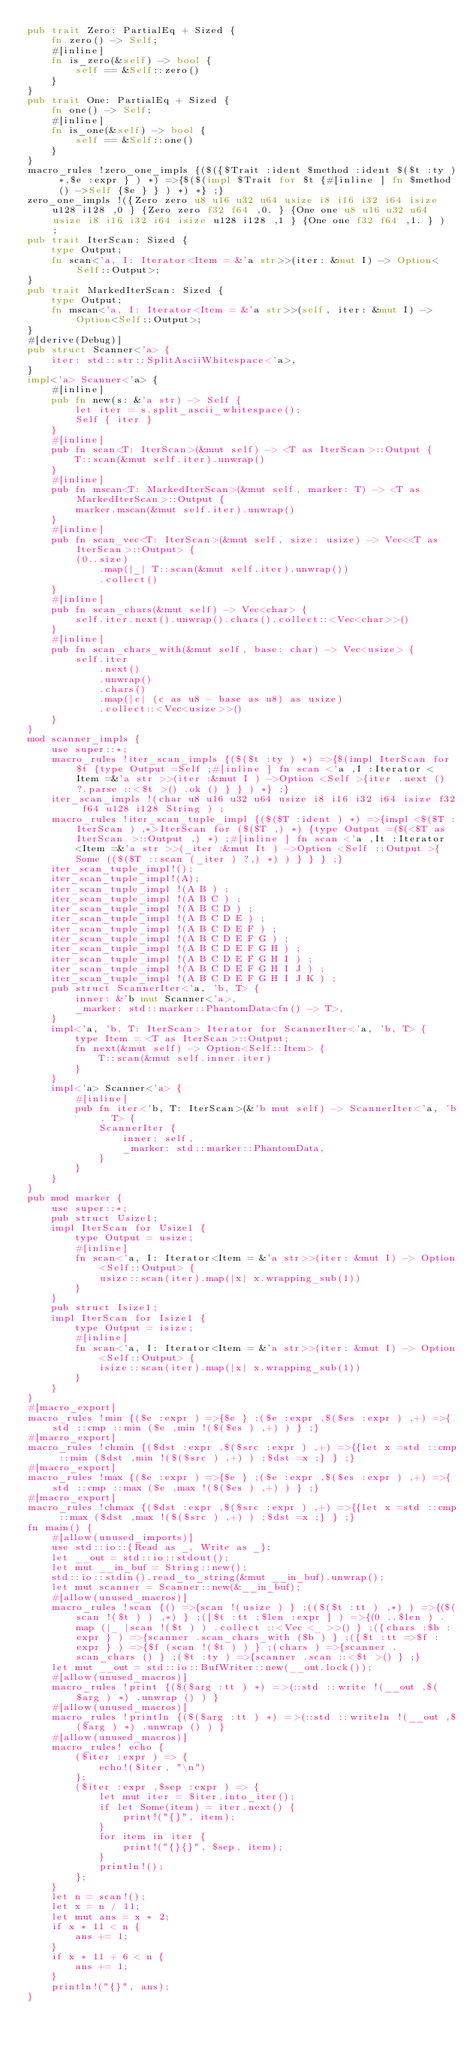Convert code to text. <code><loc_0><loc_0><loc_500><loc_500><_Rust_>pub trait Zero: PartialEq + Sized {
    fn zero() -> Self;
    #[inline]
    fn is_zero(&self) -> bool {
        self == &Self::zero()
    }
}
pub trait One: PartialEq + Sized {
    fn one() -> Self;
    #[inline]
    fn is_one(&self) -> bool {
        self == &Self::one()
    }
}
macro_rules !zero_one_impls {($({$Trait :ident $method :ident $($t :ty ) *,$e :expr } ) *) =>{$($(impl $Trait for $t {#[inline ] fn $method () ->Self {$e } } ) *) *} ;}
zero_one_impls !({Zero zero u8 u16 u32 u64 usize i8 i16 i32 i64 isize u128 i128 ,0 } {Zero zero f32 f64 ,0. } {One one u8 u16 u32 u64 usize i8 i16 i32 i64 isize u128 i128 ,1 } {One one f32 f64 ,1. } ) ;
pub trait IterScan: Sized {
    type Output;
    fn scan<'a, I: Iterator<Item = &'a str>>(iter: &mut I) -> Option<Self::Output>;
}
pub trait MarkedIterScan: Sized {
    type Output;
    fn mscan<'a, I: Iterator<Item = &'a str>>(self, iter: &mut I) -> Option<Self::Output>;
}
#[derive(Debug)]
pub struct Scanner<'a> {
    iter: std::str::SplitAsciiWhitespace<'a>,
}
impl<'a> Scanner<'a> {
    #[inline]
    pub fn new(s: &'a str) -> Self {
        let iter = s.split_ascii_whitespace();
        Self { iter }
    }
    #[inline]
    pub fn scan<T: IterScan>(&mut self) -> <T as IterScan>::Output {
        T::scan(&mut self.iter).unwrap()
    }
    #[inline]
    pub fn mscan<T: MarkedIterScan>(&mut self, marker: T) -> <T as MarkedIterScan>::Output {
        marker.mscan(&mut self.iter).unwrap()
    }
    #[inline]
    pub fn scan_vec<T: IterScan>(&mut self, size: usize) -> Vec<<T as IterScan>::Output> {
        (0..size)
            .map(|_| T::scan(&mut self.iter).unwrap())
            .collect()
    }
    #[inline]
    pub fn scan_chars(&mut self) -> Vec<char> {
        self.iter.next().unwrap().chars().collect::<Vec<char>>()
    }
    #[inline]
    pub fn scan_chars_with(&mut self, base: char) -> Vec<usize> {
        self.iter
            .next()
            .unwrap()
            .chars()
            .map(|c| (c as u8 - base as u8) as usize)
            .collect::<Vec<usize>>()
    }
}
mod scanner_impls {
    use super::*;
    macro_rules !iter_scan_impls {($($t :ty ) *) =>{$(impl IterScan for $t {type Output =Self ;#[inline ] fn scan <'a ,I :Iterator <Item =&'a str >>(iter :&mut I ) ->Option <Self >{iter .next () ?.parse ::<$t >() .ok () } } ) *} ;}
    iter_scan_impls !(char u8 u16 u32 u64 usize i8 i16 i32 i64 isize f32 f64 u128 i128 String ) ;
    macro_rules !iter_scan_tuple_impl {($($T :ident ) *) =>{impl <$($T :IterScan ) ,*>IterScan for ($($T ,) *) {type Output =($(<$T as IterScan >::Output ,) *) ;#[inline ] fn scan <'a ,It :Iterator <Item =&'a str >>(_iter :&mut It ) ->Option <Self ::Output >{Some (($($T ::scan (_iter ) ?,) *) ) } } } ;}
    iter_scan_tuple_impl!();
    iter_scan_tuple_impl!(A);
    iter_scan_tuple_impl !(A B ) ;
    iter_scan_tuple_impl !(A B C ) ;
    iter_scan_tuple_impl !(A B C D ) ;
    iter_scan_tuple_impl !(A B C D E ) ;
    iter_scan_tuple_impl !(A B C D E F ) ;
    iter_scan_tuple_impl !(A B C D E F G ) ;
    iter_scan_tuple_impl !(A B C D E F G H ) ;
    iter_scan_tuple_impl !(A B C D E F G H I ) ;
    iter_scan_tuple_impl !(A B C D E F G H I J ) ;
    iter_scan_tuple_impl !(A B C D E F G H I J K ) ;
    pub struct ScannerIter<'a, 'b, T> {
        inner: &'b mut Scanner<'a>,
        _marker: std::marker::PhantomData<fn() -> T>,
    }
    impl<'a, 'b, T: IterScan> Iterator for ScannerIter<'a, 'b, T> {
        type Item = <T as IterScan>::Output;
        fn next(&mut self) -> Option<Self::Item> {
            T::scan(&mut self.inner.iter)
        }
    }
    impl<'a> Scanner<'a> {
        #[inline]
        pub fn iter<'b, T: IterScan>(&'b mut self) -> ScannerIter<'a, 'b, T> {
            ScannerIter {
                inner: self,
                _marker: std::marker::PhantomData,
            }
        }
    }
}
pub mod marker {
    use super::*;
    pub struct Usize1;
    impl IterScan for Usize1 {
        type Output = usize;
        #[inline]
        fn scan<'a, I: Iterator<Item = &'a str>>(iter: &mut I) -> Option<Self::Output> {
            usize::scan(iter).map(|x| x.wrapping_sub(1))
        }
    }
    pub struct Isize1;
    impl IterScan for Isize1 {
        type Output = isize;
        #[inline]
        fn scan<'a, I: Iterator<Item = &'a str>>(iter: &mut I) -> Option<Self::Output> {
            isize::scan(iter).map(|x| x.wrapping_sub(1))
        }
    }
}
#[macro_export]
macro_rules !min {($e :expr ) =>{$e } ;($e :expr ,$($es :expr ) ,+) =>{std ::cmp ::min ($e ,min !($($es ) ,+) ) } ;}
#[macro_export]
macro_rules !chmin {($dst :expr ,$($src :expr ) ,+) =>{{let x =std ::cmp ::min ($dst ,min !($($src ) ,+) ) ;$dst =x ;} } ;}
#[macro_export]
macro_rules !max {($e :expr ) =>{$e } ;($e :expr ,$($es :expr ) ,+) =>{std ::cmp ::max ($e ,max !($($es ) ,+) ) } ;}
#[macro_export]
macro_rules !chmax {($dst :expr ,$($src :expr ) ,+) =>{{let x =std ::cmp ::max ($dst ,max !($($src ) ,+) ) ;$dst =x ;} } ;}
fn main() {
    #[allow(unused_imports)]
    use std::io::{Read as _, Write as _};
    let __out = std::io::stdout();
    let mut __in_buf = String::new();
    std::io::stdin().read_to_string(&mut __in_buf).unwrap();
    let mut scanner = Scanner::new(&__in_buf);
    #[allow(unused_macros)]
    macro_rules !scan {() =>{scan !(usize ) } ;(($($t :tt ) ,*) ) =>{($(scan !($t ) ) ,*) } ;([$t :tt ;$len :expr ] ) =>{(0 ..$len ) .map (|_ |scan !($t ) ) .collect ::<Vec <_ >>() } ;({chars :$b :expr } ) =>{scanner .scan_chars_with ($b ) } ;({$t :tt =>$f :expr } ) =>{$f (scan !($t ) ) } ;(chars ) =>{scanner .scan_chars () } ;($t :ty ) =>{scanner .scan ::<$t >() } ;}
    let mut __out = std::io::BufWriter::new(__out.lock());
    #[allow(unused_macros)]
    macro_rules !print {($($arg :tt ) *) =>(::std ::write !(__out ,$($arg ) *) .unwrap () ) }
    #[allow(unused_macros)]
    macro_rules !println {($($arg :tt ) *) =>(::std ::writeln !(__out ,$($arg ) *) .unwrap () ) }
    #[allow(unused_macros)]
    macro_rules! echo {
        ($iter :expr ) => {
            echo!($iter, "\n")
        };
        ($iter :expr ,$sep :expr ) => {
            let mut iter = $iter.into_iter();
            if let Some(item) = iter.next() {
                print!("{}", item);
            }
            for item in iter {
                print!("{}{}", $sep, item);
            }
            println!();
        };
    }
    let n = scan!();
    let x = n / 11;
    let mut ans = x * 2;
    if x * 11 < n {
        ans += 1;
    }
    if x * 11 + 6 < n {
        ans += 1;
    }
    println!("{}", ans);
}</code> 